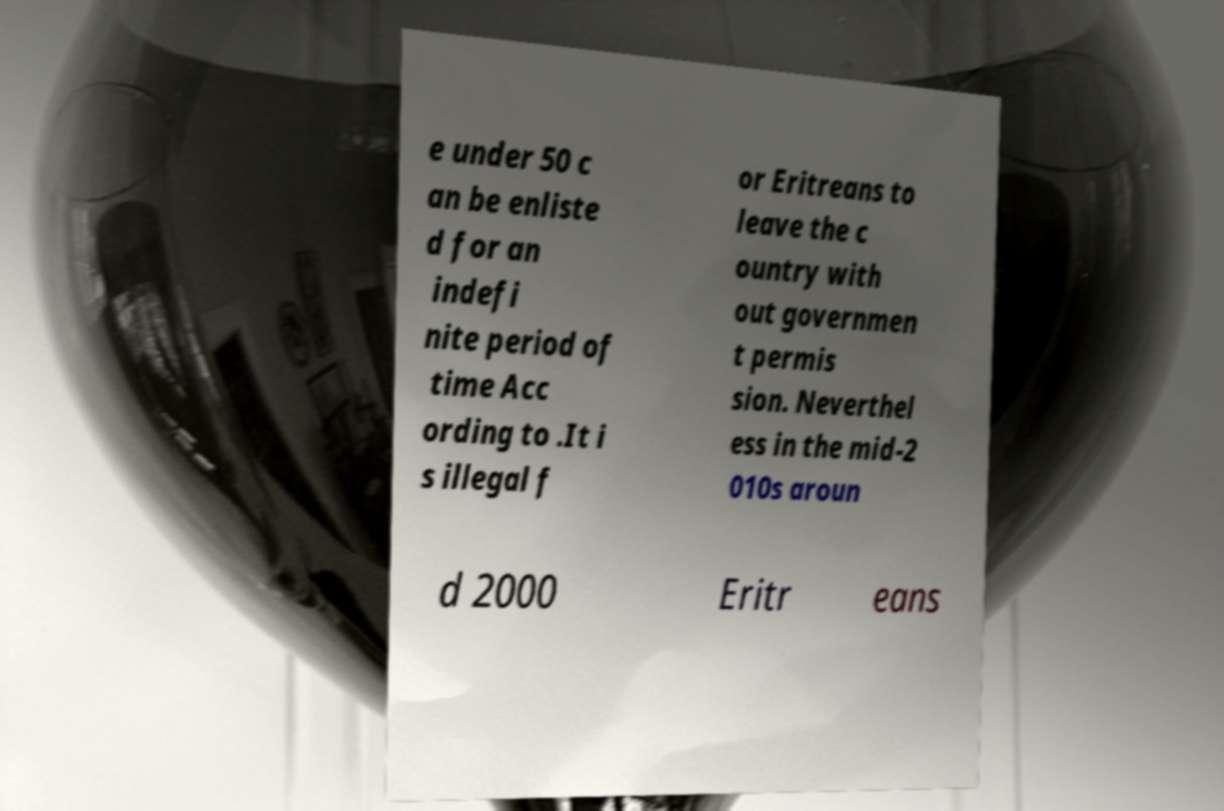Please identify and transcribe the text found in this image. e under 50 c an be enliste d for an indefi nite period of time Acc ording to .It i s illegal f or Eritreans to leave the c ountry with out governmen t permis sion. Neverthel ess in the mid-2 010s aroun d 2000 Eritr eans 